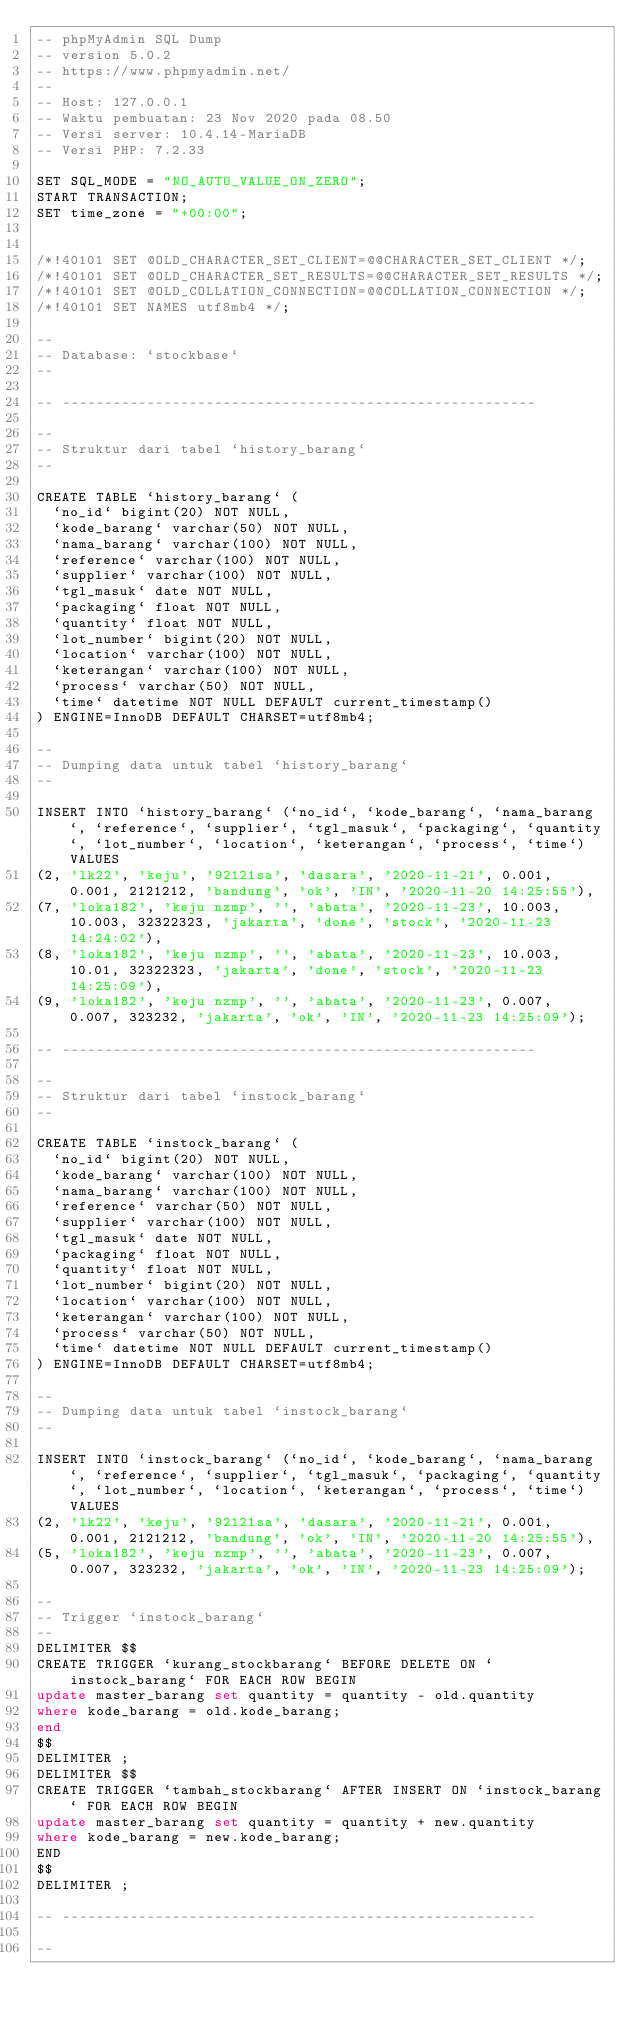<code> <loc_0><loc_0><loc_500><loc_500><_SQL_>-- phpMyAdmin SQL Dump
-- version 5.0.2
-- https://www.phpmyadmin.net/
--
-- Host: 127.0.0.1
-- Waktu pembuatan: 23 Nov 2020 pada 08.50
-- Versi server: 10.4.14-MariaDB
-- Versi PHP: 7.2.33

SET SQL_MODE = "NO_AUTO_VALUE_ON_ZERO";
START TRANSACTION;
SET time_zone = "+00:00";


/*!40101 SET @OLD_CHARACTER_SET_CLIENT=@@CHARACTER_SET_CLIENT */;
/*!40101 SET @OLD_CHARACTER_SET_RESULTS=@@CHARACTER_SET_RESULTS */;
/*!40101 SET @OLD_COLLATION_CONNECTION=@@COLLATION_CONNECTION */;
/*!40101 SET NAMES utf8mb4 */;

--
-- Database: `stockbase`
--

-- --------------------------------------------------------

--
-- Struktur dari tabel `history_barang`
--

CREATE TABLE `history_barang` (
  `no_id` bigint(20) NOT NULL,
  `kode_barang` varchar(50) NOT NULL,
  `nama_barang` varchar(100) NOT NULL,
  `reference` varchar(100) NOT NULL,
  `supplier` varchar(100) NOT NULL,
  `tgl_masuk` date NOT NULL,
  `packaging` float NOT NULL,
  `quantity` float NOT NULL,
  `lot_number` bigint(20) NOT NULL,
  `location` varchar(100) NOT NULL,
  `keterangan` varchar(100) NOT NULL,
  `process` varchar(50) NOT NULL,
  `time` datetime NOT NULL DEFAULT current_timestamp()
) ENGINE=InnoDB DEFAULT CHARSET=utf8mb4;

--
-- Dumping data untuk tabel `history_barang`
--

INSERT INTO `history_barang` (`no_id`, `kode_barang`, `nama_barang`, `reference`, `supplier`, `tgl_masuk`, `packaging`, `quantity`, `lot_number`, `location`, `keterangan`, `process`, `time`) VALUES
(2, 'lk22', 'keju', '92121sa', 'dasara', '2020-11-21', 0.001, 0.001, 2121212, 'bandung', 'ok', 'IN', '2020-11-20 14:25:55'),
(7, 'loka182', 'keju nzmp', '', 'abata', '2020-11-23', 10.003, 10.003, 32322323, 'jakarta', 'done', 'stock', '2020-11-23 14:24:02'),
(8, 'loka182', 'keju nzmp', '', 'abata', '2020-11-23', 10.003, 10.01, 32322323, 'jakarta', 'done', 'stock', '2020-11-23 14:25:09'),
(9, 'loka182', 'keju nzmp', '', 'abata', '2020-11-23', 0.007, 0.007, 323232, 'jakarta', 'ok', 'IN', '2020-11-23 14:25:09');

-- --------------------------------------------------------

--
-- Struktur dari tabel `instock_barang`
--

CREATE TABLE `instock_barang` (
  `no_id` bigint(20) NOT NULL,
  `kode_barang` varchar(100) NOT NULL,
  `nama_barang` varchar(100) NOT NULL,
  `reference` varchar(50) NOT NULL,
  `supplier` varchar(100) NOT NULL,
  `tgl_masuk` date NOT NULL,
  `packaging` float NOT NULL,
  `quantity` float NOT NULL,
  `lot_number` bigint(20) NOT NULL,
  `location` varchar(100) NOT NULL,
  `keterangan` varchar(100) NOT NULL,
  `process` varchar(50) NOT NULL,
  `time` datetime NOT NULL DEFAULT current_timestamp()
) ENGINE=InnoDB DEFAULT CHARSET=utf8mb4;

--
-- Dumping data untuk tabel `instock_barang`
--

INSERT INTO `instock_barang` (`no_id`, `kode_barang`, `nama_barang`, `reference`, `supplier`, `tgl_masuk`, `packaging`, `quantity`, `lot_number`, `location`, `keterangan`, `process`, `time`) VALUES
(2, 'lk22', 'keju', '92121sa', 'dasara', '2020-11-21', 0.001, 0.001, 2121212, 'bandung', 'ok', 'IN', '2020-11-20 14:25:55'),
(5, 'loka182', 'keju nzmp', '', 'abata', '2020-11-23', 0.007, 0.007, 323232, 'jakarta', 'ok', 'IN', '2020-11-23 14:25:09');

--
-- Trigger `instock_barang`
--
DELIMITER $$
CREATE TRIGGER `kurang_stockbarang` BEFORE DELETE ON `instock_barang` FOR EACH ROW BEGIN
update master_barang set quantity = quantity - old.quantity
where kode_barang = old.kode_barang;
end
$$
DELIMITER ;
DELIMITER $$
CREATE TRIGGER `tambah_stockbarang` AFTER INSERT ON `instock_barang` FOR EACH ROW BEGIN
update master_barang set quantity = quantity + new.quantity 
where kode_barang = new.kode_barang;
END
$$
DELIMITER ;

-- --------------------------------------------------------

--</code> 